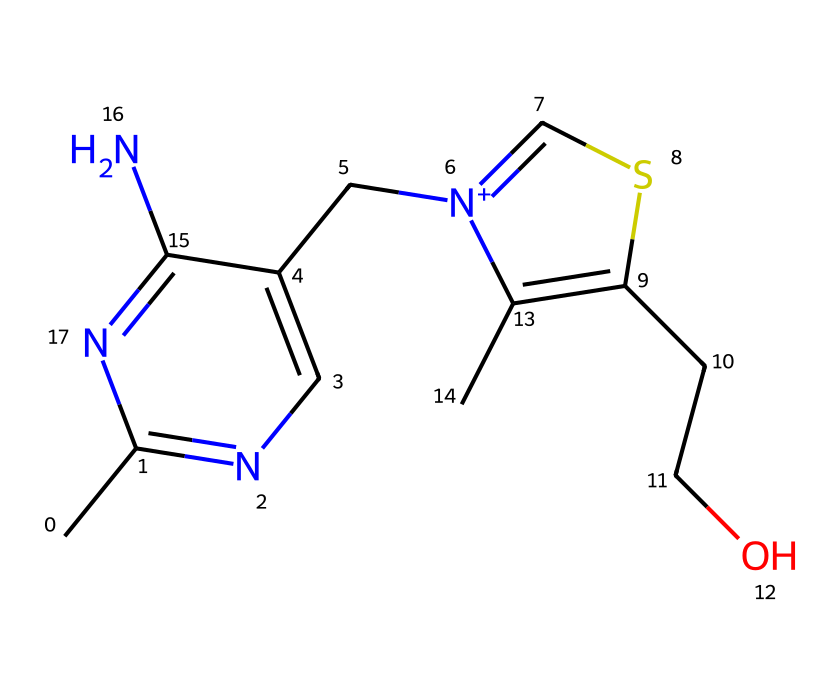What is the chemical name of the compound represented by the SMILES? The SMILES representation corresponds to thiamine, also known as vitamin B1, which is identified as a nutrient due to the presence of nitrogen and sulfur atoms in its structure.
Answer: thiamine How many sulfur atoms are in this compound? Upon examining the SMILES, there is one sulfur atom indicated by the 'S' in the structure.
Answer: one What type of functional groups are present in thiamine? The structure features amino groups (-NH2), which are indicated by the 'N' atoms, and a hydroxymethyl group (-CH2OH), evident from the 'CCO' part of the SMILES, representing key functional groups influencing its properties.
Answer: amino and hydroxymethyl Which atom in this structure is positively charged? The notation '[n+]' represents a nitrogen atom that carries a positive charge, indicating it has lost an electron, which plays a role in the compound's biochemical properties.
Answer: nitrogen What role does the sulfur atom play in thiamine's function? The sulfur atom in thiamine is involved in forming thiamine pyrophosphate, a coenzyme critical in carbohydrate metabolism, showcasing its importance in energy production process.
Answer: energy metabolism How many total carbon atoms are present in thiamine? Counting the carbon atoms indicated by the 'C' in the SMILES, there are 12 carbon atoms in total, reflecting the backbone structure of the molecule.
Answer: twelve Describe the type of compound thiamine represents. Thiamine is classified as a water-soluble vitamin, which is essential in metabolic processes, particularly in the conversion of carbohydrates into energy, highlighting its nutrient role in human health.
Answer: water-soluble vitamin 